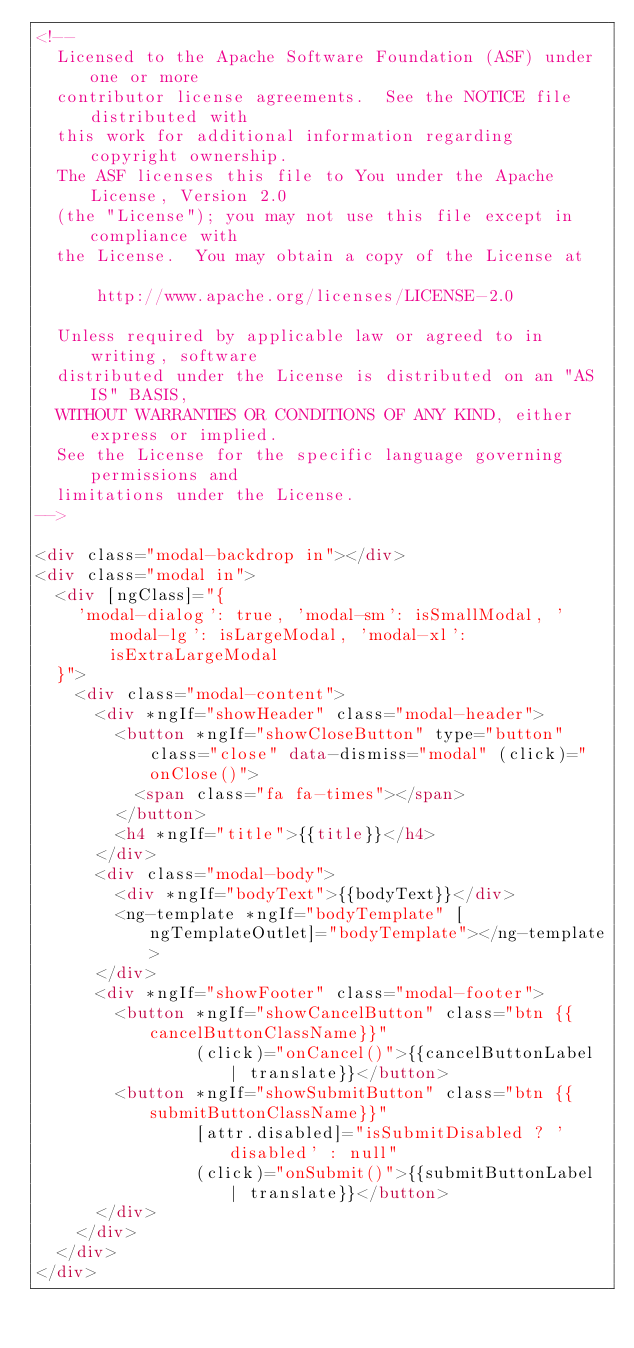<code> <loc_0><loc_0><loc_500><loc_500><_HTML_><!--
  Licensed to the Apache Software Foundation (ASF) under one or more
  contributor license agreements.  See the NOTICE file distributed with
  this work for additional information regarding copyright ownership.
  The ASF licenses this file to You under the Apache License, Version 2.0
  (the "License"); you may not use this file except in compliance with
  the License.  You may obtain a copy of the License at

      http://www.apache.org/licenses/LICENSE-2.0

  Unless required by applicable law or agreed to in writing, software
  distributed under the License is distributed on an "AS IS" BASIS,
  WITHOUT WARRANTIES OR CONDITIONS OF ANY KIND, either express or implied.
  See the License for the specific language governing permissions and
  limitations under the License.
-->

<div class="modal-backdrop in"></div>
<div class="modal in">
  <div [ngClass]="{
    'modal-dialog': true, 'modal-sm': isSmallModal, 'modal-lg': isLargeModal, 'modal-xl': isExtraLargeModal
  }">
    <div class="modal-content">
      <div *ngIf="showHeader" class="modal-header">
        <button *ngIf="showCloseButton" type="button" class="close" data-dismiss="modal" (click)="onClose()">
          <span class="fa fa-times"></span>
        </button>
        <h4 *ngIf="title">{{title}}</h4>
      </div>
      <div class="modal-body">
        <div *ngIf="bodyText">{{bodyText}}</div>
        <ng-template *ngIf="bodyTemplate" [ngTemplateOutlet]="bodyTemplate"></ng-template>
      </div>
      <div *ngIf="showFooter" class="modal-footer">
        <button *ngIf="showCancelButton" class="btn {{cancelButtonClassName}}"
                (click)="onCancel()">{{cancelButtonLabel | translate}}</button>
        <button *ngIf="showSubmitButton" class="btn {{submitButtonClassName}}"
                [attr.disabled]="isSubmitDisabled ? 'disabled' : null"
                (click)="onSubmit()">{{submitButtonLabel | translate}}</button>
      </div>
    </div>
  </div>
</div>
</code> 